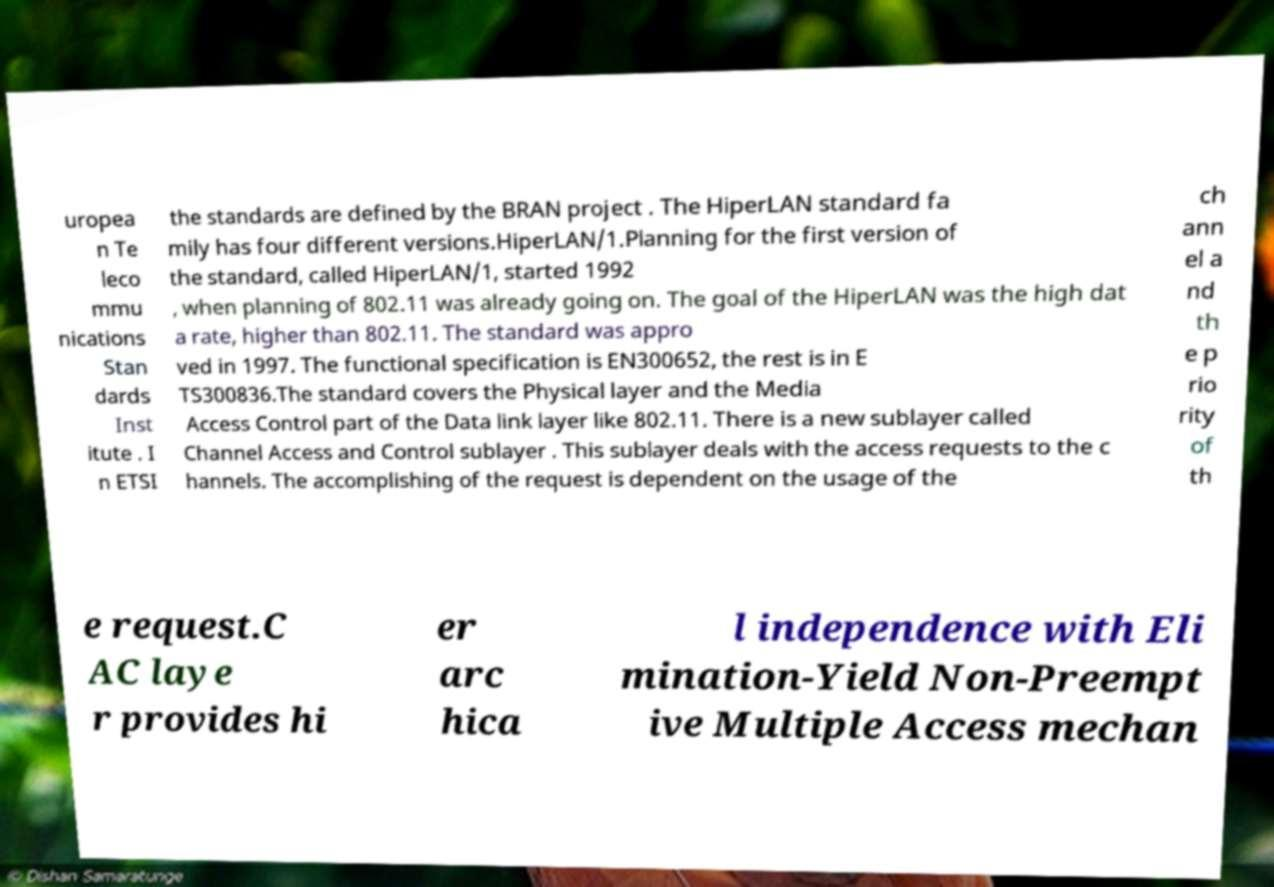I need the written content from this picture converted into text. Can you do that? uropea n Te leco mmu nications Stan dards Inst itute . I n ETSI the standards are defined by the BRAN project . The HiperLAN standard fa mily has four different versions.HiperLAN/1.Planning for the first version of the standard, called HiperLAN/1, started 1992 , when planning of 802.11 was already going on. The goal of the HiperLAN was the high dat a rate, higher than 802.11. The standard was appro ved in 1997. The functional specification is EN300652, the rest is in E TS300836.The standard covers the Physical layer and the Media Access Control part of the Data link layer like 802.11. There is a new sublayer called Channel Access and Control sublayer . This sublayer deals with the access requests to the c hannels. The accomplishing of the request is dependent on the usage of the ch ann el a nd th e p rio rity of th e request.C AC laye r provides hi er arc hica l independence with Eli mination-Yield Non-Preempt ive Multiple Access mechan 